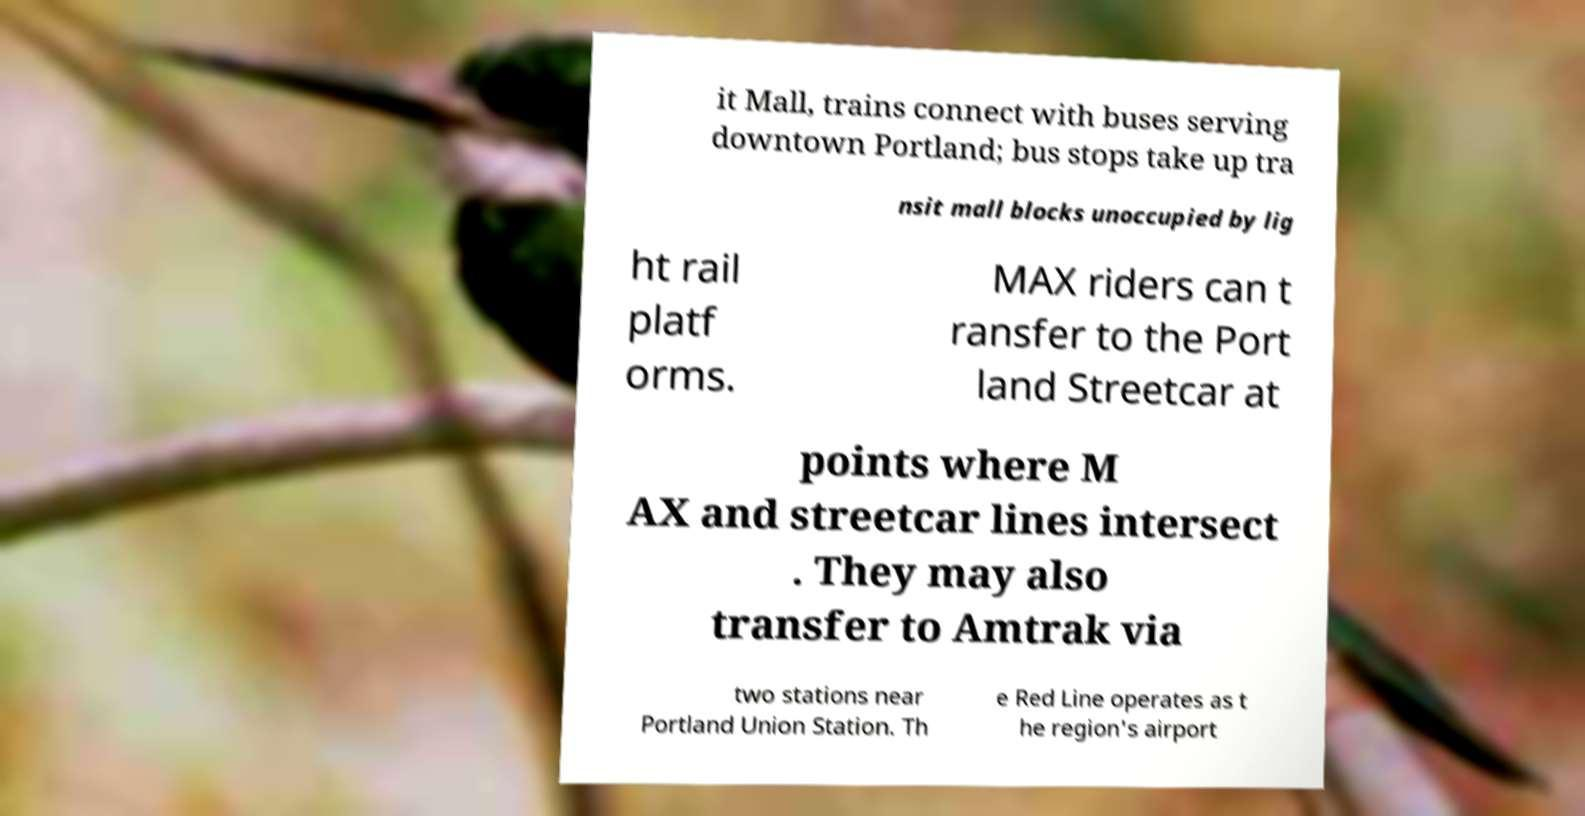Could you assist in decoding the text presented in this image and type it out clearly? it Mall, trains connect with buses serving downtown Portland; bus stops take up tra nsit mall blocks unoccupied by lig ht rail platf orms. MAX riders can t ransfer to the Port land Streetcar at points where M AX and streetcar lines intersect . They may also transfer to Amtrak via two stations near Portland Union Station. Th e Red Line operates as t he region's airport 